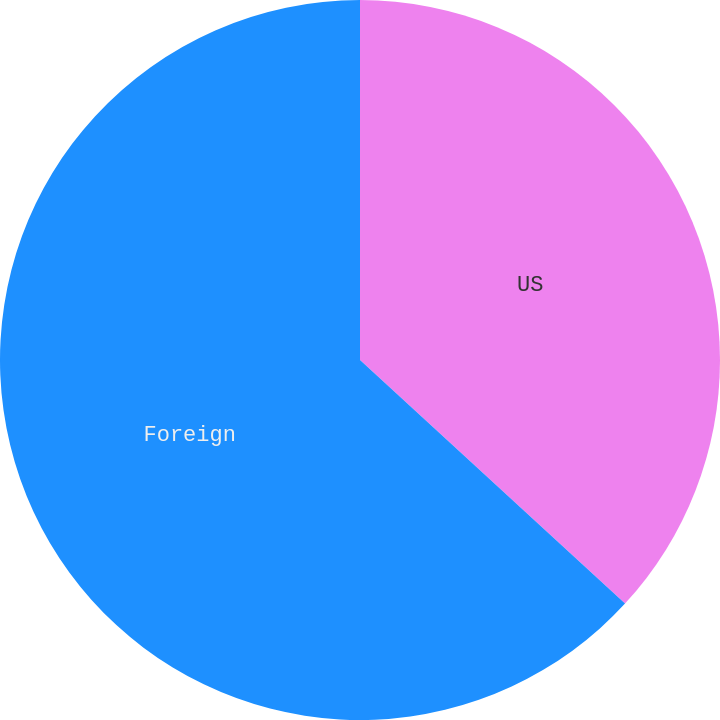Convert chart. <chart><loc_0><loc_0><loc_500><loc_500><pie_chart><fcel>US<fcel>Foreign<nl><fcel>36.83%<fcel>63.17%<nl></chart> 